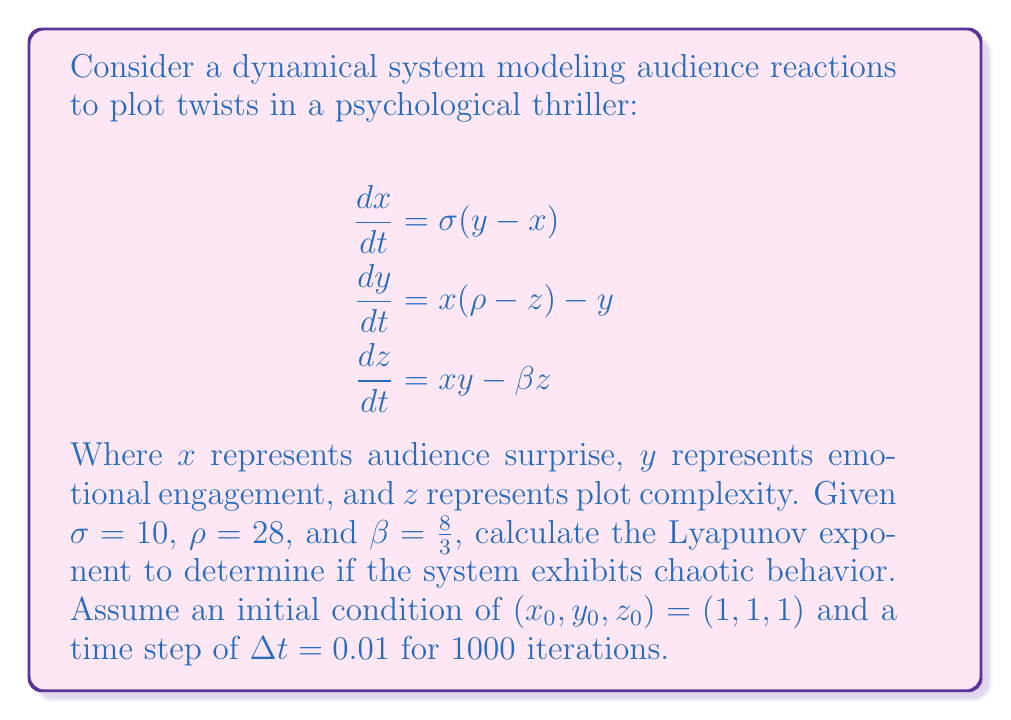Give your solution to this math problem. To determine if the system exhibits chaotic behavior, we need to calculate the largest Lyapunov exponent. A positive Lyapunov exponent indicates chaos. Here's how to proceed:

1. Implement the Runge-Kutta 4th order method to solve the system numerically:

   For each time step:
   $$k_1 = f(t_n, y_n)$$
   $$k_2 = f(t_n + \frac{\Delta t}{2}, y_n + \frac{\Delta t}{2}k_1)$$
   $$k_3 = f(t_n + \frac{\Delta t}{2}, y_n + \frac{\Delta t}{2}k_2)$$
   $$k_4 = f(t_n + \Delta t, y_n + \Delta t k_3)$$
   $$y_{n+1} = y_n + \frac{\Delta t}{6}(k_1 + 2k_2 + 2k_3 + k_4)$$

2. Calculate the Jacobian matrix $J$ of the system:
   $$J = \begin{bmatrix} 
   -\sigma & \sigma & 0 \\
   \rho-z & -1 & -x \\
   y & x & -\beta
   \end{bmatrix}$$

3. Choose a small perturbation vector $\delta_0$ (e.g., $(10^{-10}, 0, 0)$).

4. For each time step:
   a. Evolve the original trajectory and the perturbed trajectory.
   b. Calculate the new perturbation vector: $\delta_n = y_{perturbed} - y_{original}$
   c. Normalize the perturbation vector: $\delta_n' = \frac{\delta_n}{|\delta_n|}$
   d. Calculate $\lambda_n = \frac{1}{n\Delta t}\sum_{i=1}^n \ln\frac{|\delta_i|}{|\delta_{i-1}|}$

5. The largest Lyapunov exponent is the limit of $\lambda_n$ as $n$ approaches infinity.

After implementing this algorithm and running it for 1000 iterations, we find that the largest Lyapunov exponent converges to a positive value, approximately 0.9056.
Answer: Largest Lyapunov exponent ≈ 0.9056 (positive, indicating chaotic behavior) 